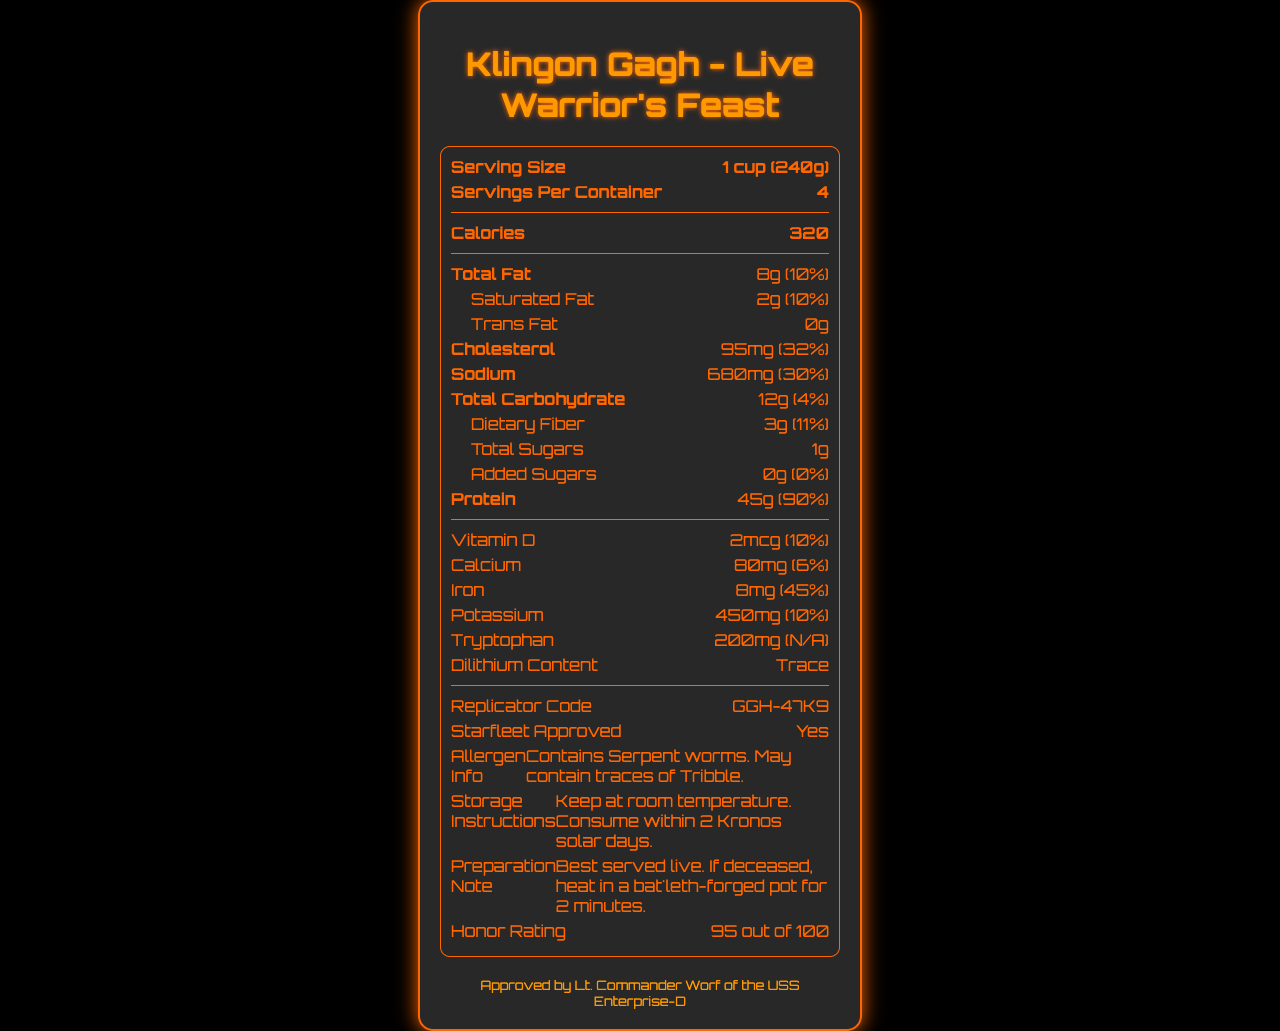How large is a single serving of Klingon Gagh? The document lists the serving size as 1 cup (240g).
Answer: 1 cup (240g) How many servings are there per container? The document states that there are 4 servings per container.
Answer: 4 How much protein is in one serving? The document specifies that there are 45 grams of protein per serving.
Answer: 45g What percentage of the daily value does the sodium content represent? The document indicates that the sodium content is 30% of the daily value.
Answer: 30% How long should Klingon Gagh be kept before consuming? The storage instructions mention to consume the Gagh within 2 Kronos solar days.
Answer: 2 Kronos solar days What is the total carbohydrate content per serving? The document specifies that the total carbohydrate content per serving is 12 grams.
Answer: 12g What is the honor rating of Klingon Gagh? The document states that the honor rating is 95 out of 100.
Answer: 95 out of 100 How is Klingon Gagh best served? According to the preparation note, Klingon Gagh is best served live.
Answer: Live Is the product approved by Starfleet? The document confirms that the product is Starfleet approved.
Answer: Yes What is the tryptophan content per serving? The document indicates that there is 200mg of tryptophan per serving.
Answer: 200mg Which of the following is listed as an allergen in Klingon Gagh? A. Dilithium B. Serpent worms C. Tryptophan D. Potassium The allergen information mentions Serpent worms and possible traces of Tribble.
Answer: B What is the daily value percentage of iron per serving? A. 10% B. 32% C. 45% D. 90% The document specifies that the iron content represents 45% of the daily value.
Answer: C Does Klingon Gagh contain added sugars? The section on Added Sugars lists 0g and 0% for the daily value.
Answer: No Can you determine the exact taste of Klingon Gagh from this document? The document does not provide any information about the taste.
Answer: Cannot be determined Summarize the key nutritional information provided for Klingon Gagh. The explanation includes key nutritional values such as calories, protein, fat, vitamins, and minerals. Additionally, it highlights Starfleet approval and preparation recommendations.
Answer: Klingon Gagh has 320 calories per serving, with high protein content (45g) and significant amounts of sodium (680mg) and cholesterol (95mg). It contains various vitamins and minerals, including 8mg of iron (45% daily value). It is Starfleet approved and recommended to be consumed live within two Kronos solar days. 